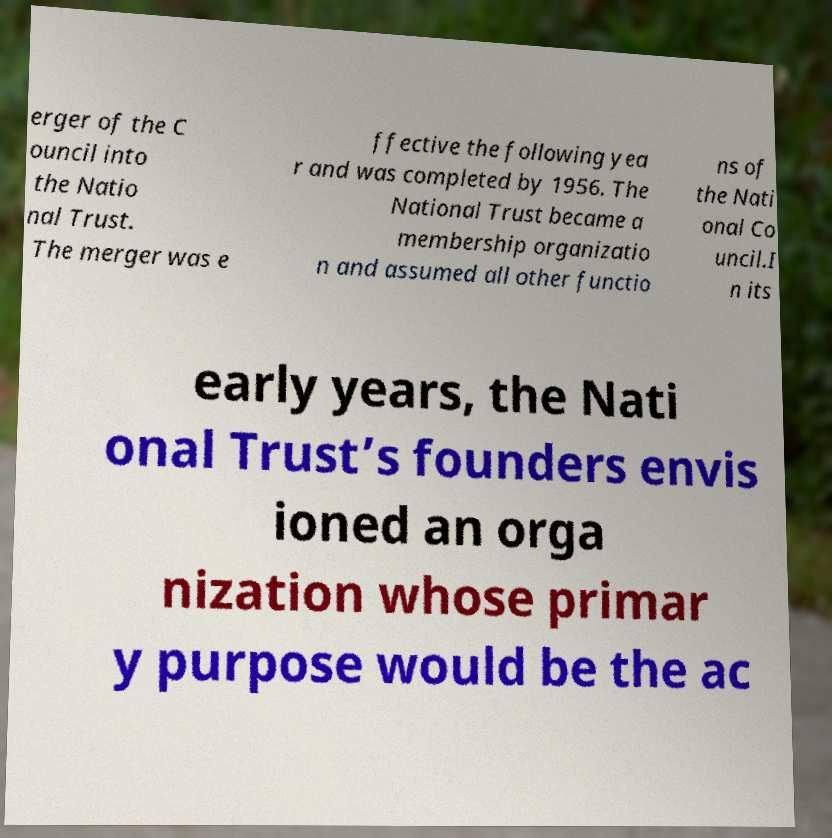I need the written content from this picture converted into text. Can you do that? erger of the C ouncil into the Natio nal Trust. The merger was e ffective the following yea r and was completed by 1956. The National Trust became a membership organizatio n and assumed all other functio ns of the Nati onal Co uncil.I n its early years, the Nati onal Trust’s founders envis ioned an orga nization whose primar y purpose would be the ac 